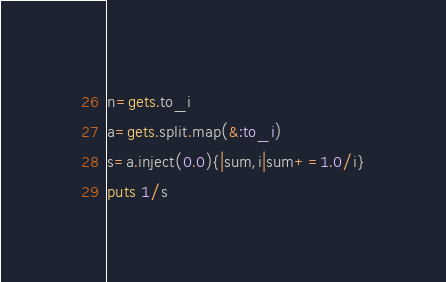Convert code to text. <code><loc_0><loc_0><loc_500><loc_500><_Ruby_>n=gets.to_i
a=gets.split.map(&:to_i)
s=a.inject(0.0){|sum,i|sum+=1.0/i}
puts 1/s
</code> 